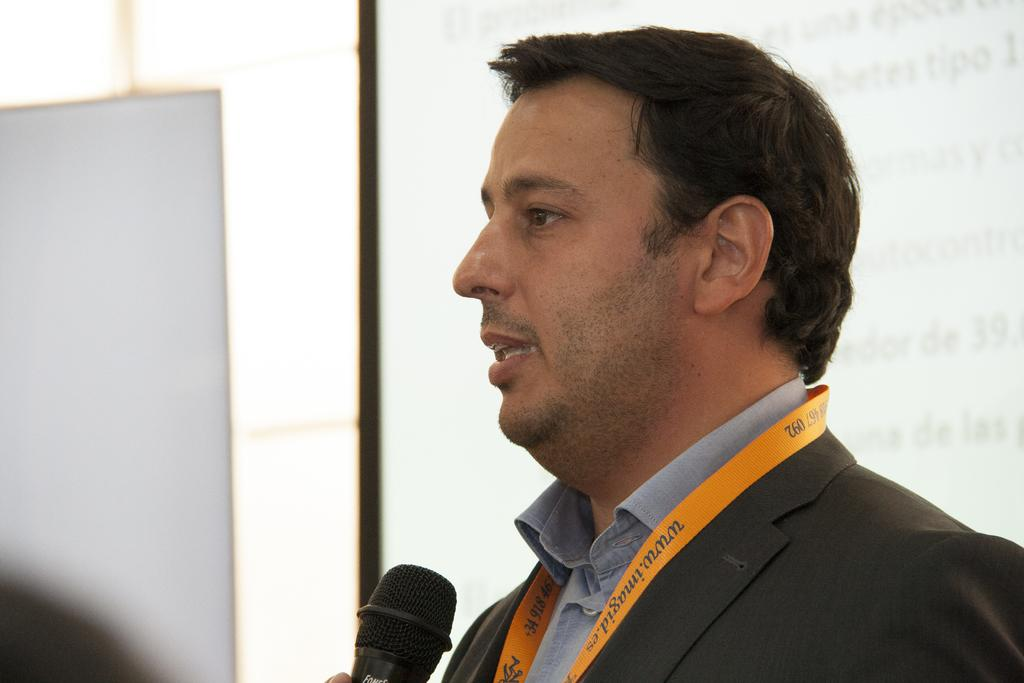Who is present in the image? There is a man in the image. What is the man holding in the image? The man is holding a microphone. What is the man wearing in the image? The man is wearing a suit. What can be seen in the background of the image? There is a screen in the background of the image. What type of picture is hanging on the wall in the image? There is no picture hanging on the wall in the image. Is there a volleyball game being played in the image? No, there is no volleyball game present in the image. What season is depicted in the image? The image does not depict a specific season, as there are no seasonal cues present. 